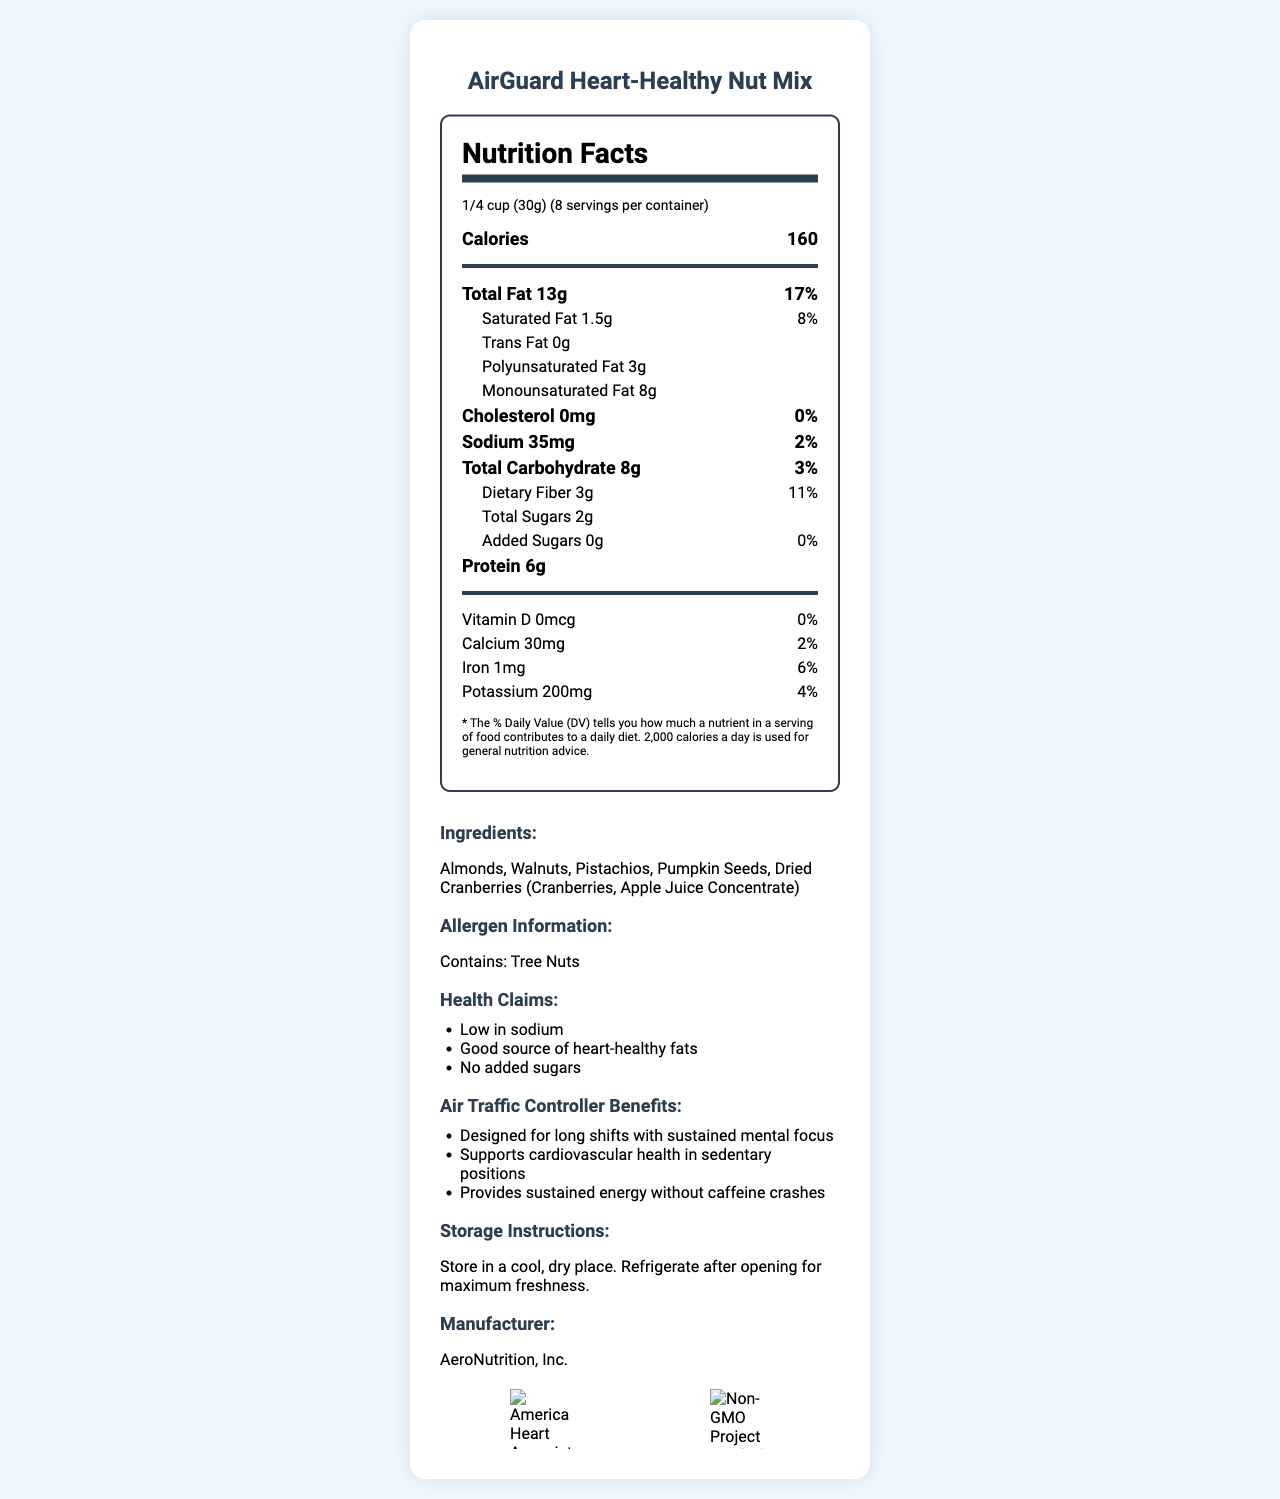what is the product name? The product name is stated at the beginning of the document as "AirGuard Heart-Healthy Nut Mix".
Answer: AirGuard Heart-Healthy Nut Mix how many servings are in the container? The document states that there are 8 servings per container.
Answer: 8 how many calories are in one serving? The number of calories per serving is listed as 160.
Answer: 160 what is the serving size? The serving size is displayed as 1/4 cup (30g).
Answer: 1/4 cup (30g) what is the amount of total fat per serving? The document lists the total fat per serving as 13g.
Answer: 13g what is the daily value percentage for saturated fat? The daily value percentage for saturated fat is noted as 8%.
Answer: 8% how much sodium is there per serving? The sodium content per serving is listed as 35mg.
Answer: 35mg what type of fats are included in the nut mix? The document mentions polyunsaturated fat (3g) and monounsaturated fat (8g).
Answer: Polyunsaturated fat and monounsaturated fat how much protein is in a serving? The protein amount per serving is listed as 6g.
Answer: 6g how much dietary fiber can be found per serving? The document states that there are 3g of dietary fiber per serving.
Answer: 3g which of the following are ingredients in the AirGuard Heart-Healthy Nut Mix? A) Almonds B) Peanuts C) Dried Cranberries D) Walnuts The ingredients listed in the document include almonds, walnuts, pistachios, pumpkin seeds, and dried cranberries (cranberries, apple juice concentrate).
Answer: A, C, D which health claim is NOT made about this product? A) Low in sodium B) No caffeine C) No added sugars The document states the health claims as "Low in sodium", "Good source of heart-healthy fats", and "No added sugars", but it does not mention "No caffeine".
Answer: B does the nut mix contain any cholesterol? The document states that the cholesterol content is 0mg, which means it contains no cholesterol.
Answer: No is this snack suitable for someone with a tree nut allergy? The allergen information clearly states that the product contains tree nuts.
Answer: No summarize the main benefits of the AirGuard Heart-Healthy Nut Mix for air traffic controllers. The document mentions these benefits directly under "Air Traffic Controller Benefits".
Answer: The AirGuard Heart-Healthy Nut Mix is designed for long shifts with sustained mental focus. It supports cardiovascular health in sedentary positions and provides sustained energy without caffeine crashes. how many certifications does this product have? The product has two certifications: American Heart Association Certified and Non-GMO Project Verified.
Answer: 2 who is the manufacturer of the AirGuard Heart-Healthy Nut Mix? The document states that the manufacturer is AeroNutrition, Inc.
Answer: AeroNutrition, Inc. what type of packaging is used for this product? The packaging is described as resealable, single-serving pouches.
Answer: Resealable, single-serving pouches what is the exact potassium content per serving? The potassium content per serving is listed as 200mg.
Answer: 200mg where should the nut mix be stored after opening? The storage instructions advise refrigerating the product after opening for maximum freshness.
Answer: In a refrigerator what is the price of the AirGuard Heart-Healthy Nut Mix? The document does not provide any information about the price of the product.
Answer: Cannot be determined 